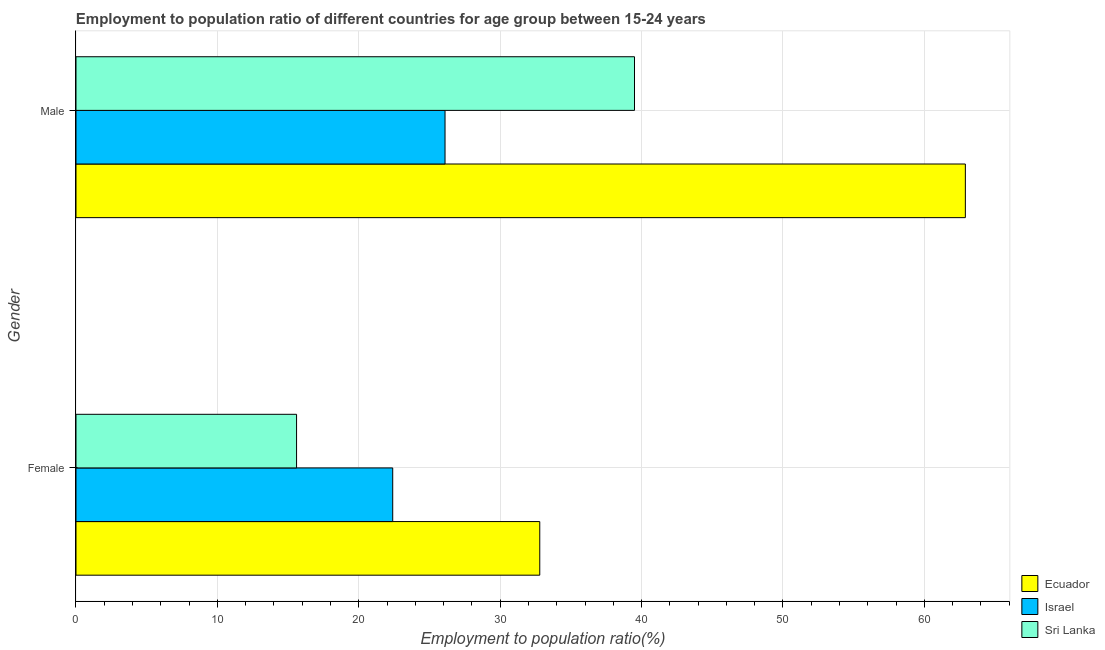How many groups of bars are there?
Provide a succinct answer. 2. Are the number of bars per tick equal to the number of legend labels?
Your response must be concise. Yes. How many bars are there on the 2nd tick from the top?
Offer a terse response. 3. How many bars are there on the 2nd tick from the bottom?
Give a very brief answer. 3. What is the label of the 1st group of bars from the top?
Provide a short and direct response. Male. What is the employment to population ratio(male) in Ecuador?
Provide a short and direct response. 62.9. Across all countries, what is the maximum employment to population ratio(female)?
Your answer should be compact. 32.8. Across all countries, what is the minimum employment to population ratio(female)?
Give a very brief answer. 15.6. In which country was the employment to population ratio(female) maximum?
Offer a terse response. Ecuador. In which country was the employment to population ratio(male) minimum?
Provide a succinct answer. Israel. What is the total employment to population ratio(female) in the graph?
Give a very brief answer. 70.8. What is the difference between the employment to population ratio(male) in Ecuador and that in Sri Lanka?
Keep it short and to the point. 23.4. What is the difference between the employment to population ratio(female) in Sri Lanka and the employment to population ratio(male) in Israel?
Your answer should be very brief. -10.5. What is the average employment to population ratio(female) per country?
Give a very brief answer. 23.6. What is the difference between the employment to population ratio(male) and employment to population ratio(female) in Ecuador?
Ensure brevity in your answer.  30.1. In how many countries, is the employment to population ratio(male) greater than 26 %?
Your answer should be compact. 3. What is the ratio of the employment to population ratio(male) in Ecuador to that in Sri Lanka?
Your answer should be compact. 1.59. In how many countries, is the employment to population ratio(male) greater than the average employment to population ratio(male) taken over all countries?
Your response must be concise. 1. What does the 1st bar from the bottom in Male represents?
Provide a succinct answer. Ecuador. How many countries are there in the graph?
Your response must be concise. 3. What is the difference between two consecutive major ticks on the X-axis?
Offer a terse response. 10. Are the values on the major ticks of X-axis written in scientific E-notation?
Your response must be concise. No. Where does the legend appear in the graph?
Provide a short and direct response. Bottom right. What is the title of the graph?
Your response must be concise. Employment to population ratio of different countries for age group between 15-24 years. Does "Djibouti" appear as one of the legend labels in the graph?
Offer a terse response. No. What is the label or title of the X-axis?
Give a very brief answer. Employment to population ratio(%). What is the Employment to population ratio(%) of Ecuador in Female?
Your answer should be compact. 32.8. What is the Employment to population ratio(%) in Israel in Female?
Offer a terse response. 22.4. What is the Employment to population ratio(%) of Sri Lanka in Female?
Provide a succinct answer. 15.6. What is the Employment to population ratio(%) of Ecuador in Male?
Ensure brevity in your answer.  62.9. What is the Employment to population ratio(%) in Israel in Male?
Provide a succinct answer. 26.1. What is the Employment to population ratio(%) of Sri Lanka in Male?
Provide a succinct answer. 39.5. Across all Gender, what is the maximum Employment to population ratio(%) in Ecuador?
Your answer should be very brief. 62.9. Across all Gender, what is the maximum Employment to population ratio(%) in Israel?
Offer a terse response. 26.1. Across all Gender, what is the maximum Employment to population ratio(%) in Sri Lanka?
Your answer should be very brief. 39.5. Across all Gender, what is the minimum Employment to population ratio(%) in Ecuador?
Provide a succinct answer. 32.8. Across all Gender, what is the minimum Employment to population ratio(%) in Israel?
Your answer should be very brief. 22.4. Across all Gender, what is the minimum Employment to population ratio(%) in Sri Lanka?
Offer a very short reply. 15.6. What is the total Employment to population ratio(%) in Ecuador in the graph?
Provide a succinct answer. 95.7. What is the total Employment to population ratio(%) in Israel in the graph?
Provide a short and direct response. 48.5. What is the total Employment to population ratio(%) of Sri Lanka in the graph?
Give a very brief answer. 55.1. What is the difference between the Employment to population ratio(%) in Ecuador in Female and that in Male?
Ensure brevity in your answer.  -30.1. What is the difference between the Employment to population ratio(%) in Israel in Female and that in Male?
Your answer should be very brief. -3.7. What is the difference between the Employment to population ratio(%) in Sri Lanka in Female and that in Male?
Your response must be concise. -23.9. What is the difference between the Employment to population ratio(%) of Ecuador in Female and the Employment to population ratio(%) of Israel in Male?
Ensure brevity in your answer.  6.7. What is the difference between the Employment to population ratio(%) of Ecuador in Female and the Employment to population ratio(%) of Sri Lanka in Male?
Offer a very short reply. -6.7. What is the difference between the Employment to population ratio(%) of Israel in Female and the Employment to population ratio(%) of Sri Lanka in Male?
Offer a terse response. -17.1. What is the average Employment to population ratio(%) of Ecuador per Gender?
Offer a terse response. 47.85. What is the average Employment to population ratio(%) in Israel per Gender?
Offer a very short reply. 24.25. What is the average Employment to population ratio(%) in Sri Lanka per Gender?
Offer a very short reply. 27.55. What is the difference between the Employment to population ratio(%) in Israel and Employment to population ratio(%) in Sri Lanka in Female?
Your answer should be very brief. 6.8. What is the difference between the Employment to population ratio(%) in Ecuador and Employment to population ratio(%) in Israel in Male?
Keep it short and to the point. 36.8. What is the difference between the Employment to population ratio(%) in Ecuador and Employment to population ratio(%) in Sri Lanka in Male?
Make the answer very short. 23.4. What is the difference between the Employment to population ratio(%) in Israel and Employment to population ratio(%) in Sri Lanka in Male?
Offer a terse response. -13.4. What is the ratio of the Employment to population ratio(%) in Ecuador in Female to that in Male?
Ensure brevity in your answer.  0.52. What is the ratio of the Employment to population ratio(%) in Israel in Female to that in Male?
Your response must be concise. 0.86. What is the ratio of the Employment to population ratio(%) of Sri Lanka in Female to that in Male?
Provide a succinct answer. 0.39. What is the difference between the highest and the second highest Employment to population ratio(%) in Ecuador?
Keep it short and to the point. 30.1. What is the difference between the highest and the second highest Employment to population ratio(%) in Sri Lanka?
Offer a terse response. 23.9. What is the difference between the highest and the lowest Employment to population ratio(%) in Ecuador?
Give a very brief answer. 30.1. What is the difference between the highest and the lowest Employment to population ratio(%) of Israel?
Provide a short and direct response. 3.7. What is the difference between the highest and the lowest Employment to population ratio(%) in Sri Lanka?
Provide a short and direct response. 23.9. 